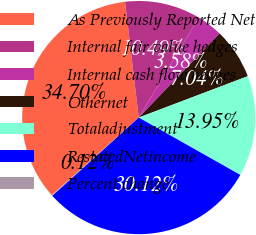Convert chart. <chart><loc_0><loc_0><loc_500><loc_500><pie_chart><fcel>As Previously Reported Net<fcel>Internal fair value hedges<fcel>Internal cash flow hedges<fcel>Othernet<fcel>Totaladjustment<fcel>RestatedNetincome<fcel>Percent change<nl><fcel>34.7%<fcel>10.49%<fcel>3.58%<fcel>7.04%<fcel>13.95%<fcel>30.12%<fcel>0.12%<nl></chart> 